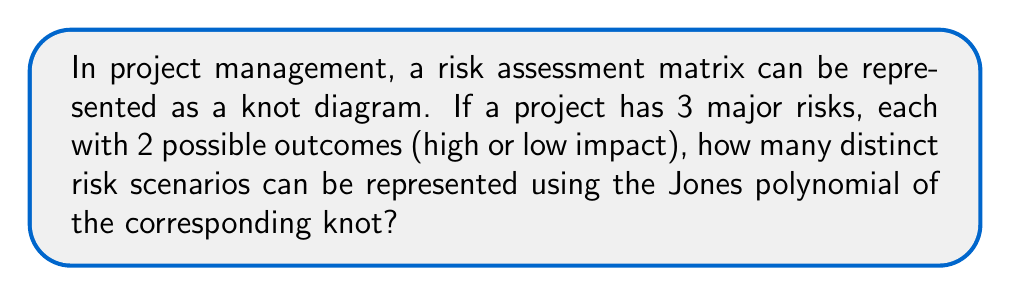Teach me how to tackle this problem. To solve this problem, we'll follow these steps:

1) First, we need to understand how the risk scenarios can be represented as a knot. Each risk can be thought of as a strand in the knot, and the outcomes (high or low impact) can be represented by how these strands cross each other.

2) With 3 risks and 2 outcomes each, we essentially have a 3-strand braid with 2 possible crossings at each point. This is analogous to a 3-strand braid in knot theory.

3) The number of distinct 3-strand braids with n crossings is given by the formula:

   $$3^n$$

   Where n is the number of crossings.

4) In our case, we have 3 risks, each with 2 possible outcomes, so we have 3 potential crossing points. Therefore, n = 3.

5) Plugging this into our formula:

   $$3^3 = 27$$

6) However, the Jones polynomial doesn't distinguish between some knots that are actually different. For 3-strand braids, it's known that the Jones polynomial can distinguish up to 23 different knots.

7) Therefore, while there are 27 distinct risk scenarios, the Jones polynomial can represent 23 of these as distinct polynomials.
Answer: 23 